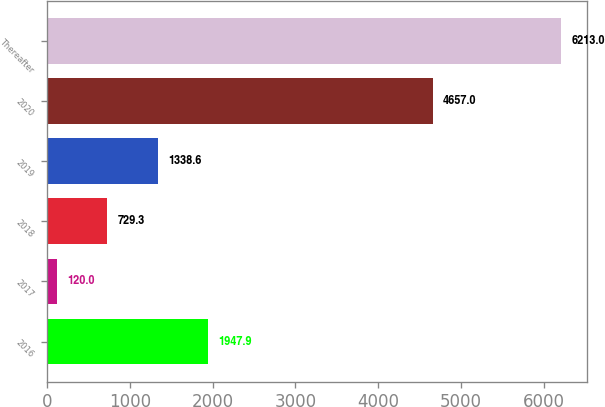<chart> <loc_0><loc_0><loc_500><loc_500><bar_chart><fcel>2016<fcel>2017<fcel>2018<fcel>2019<fcel>2020<fcel>Thereafter<nl><fcel>1947.9<fcel>120<fcel>729.3<fcel>1338.6<fcel>4657<fcel>6213<nl></chart> 